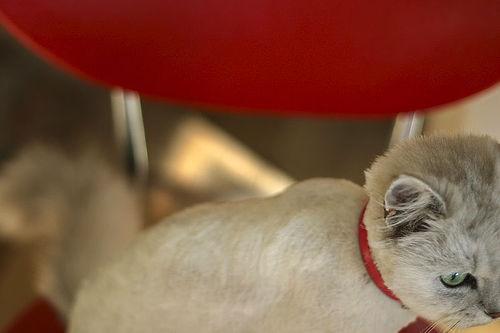Does this cat appear to be fully grown?
Write a very short answer. No. What color is the cat?
Give a very brief answer. Gray. Is the cat napping?
Be succinct. No. What is the cat sitting on?
Concise answer only. Chair. What color is the cat's collar?
Answer briefly. Red. Where is the red plate?
Give a very brief answer. No plate. 